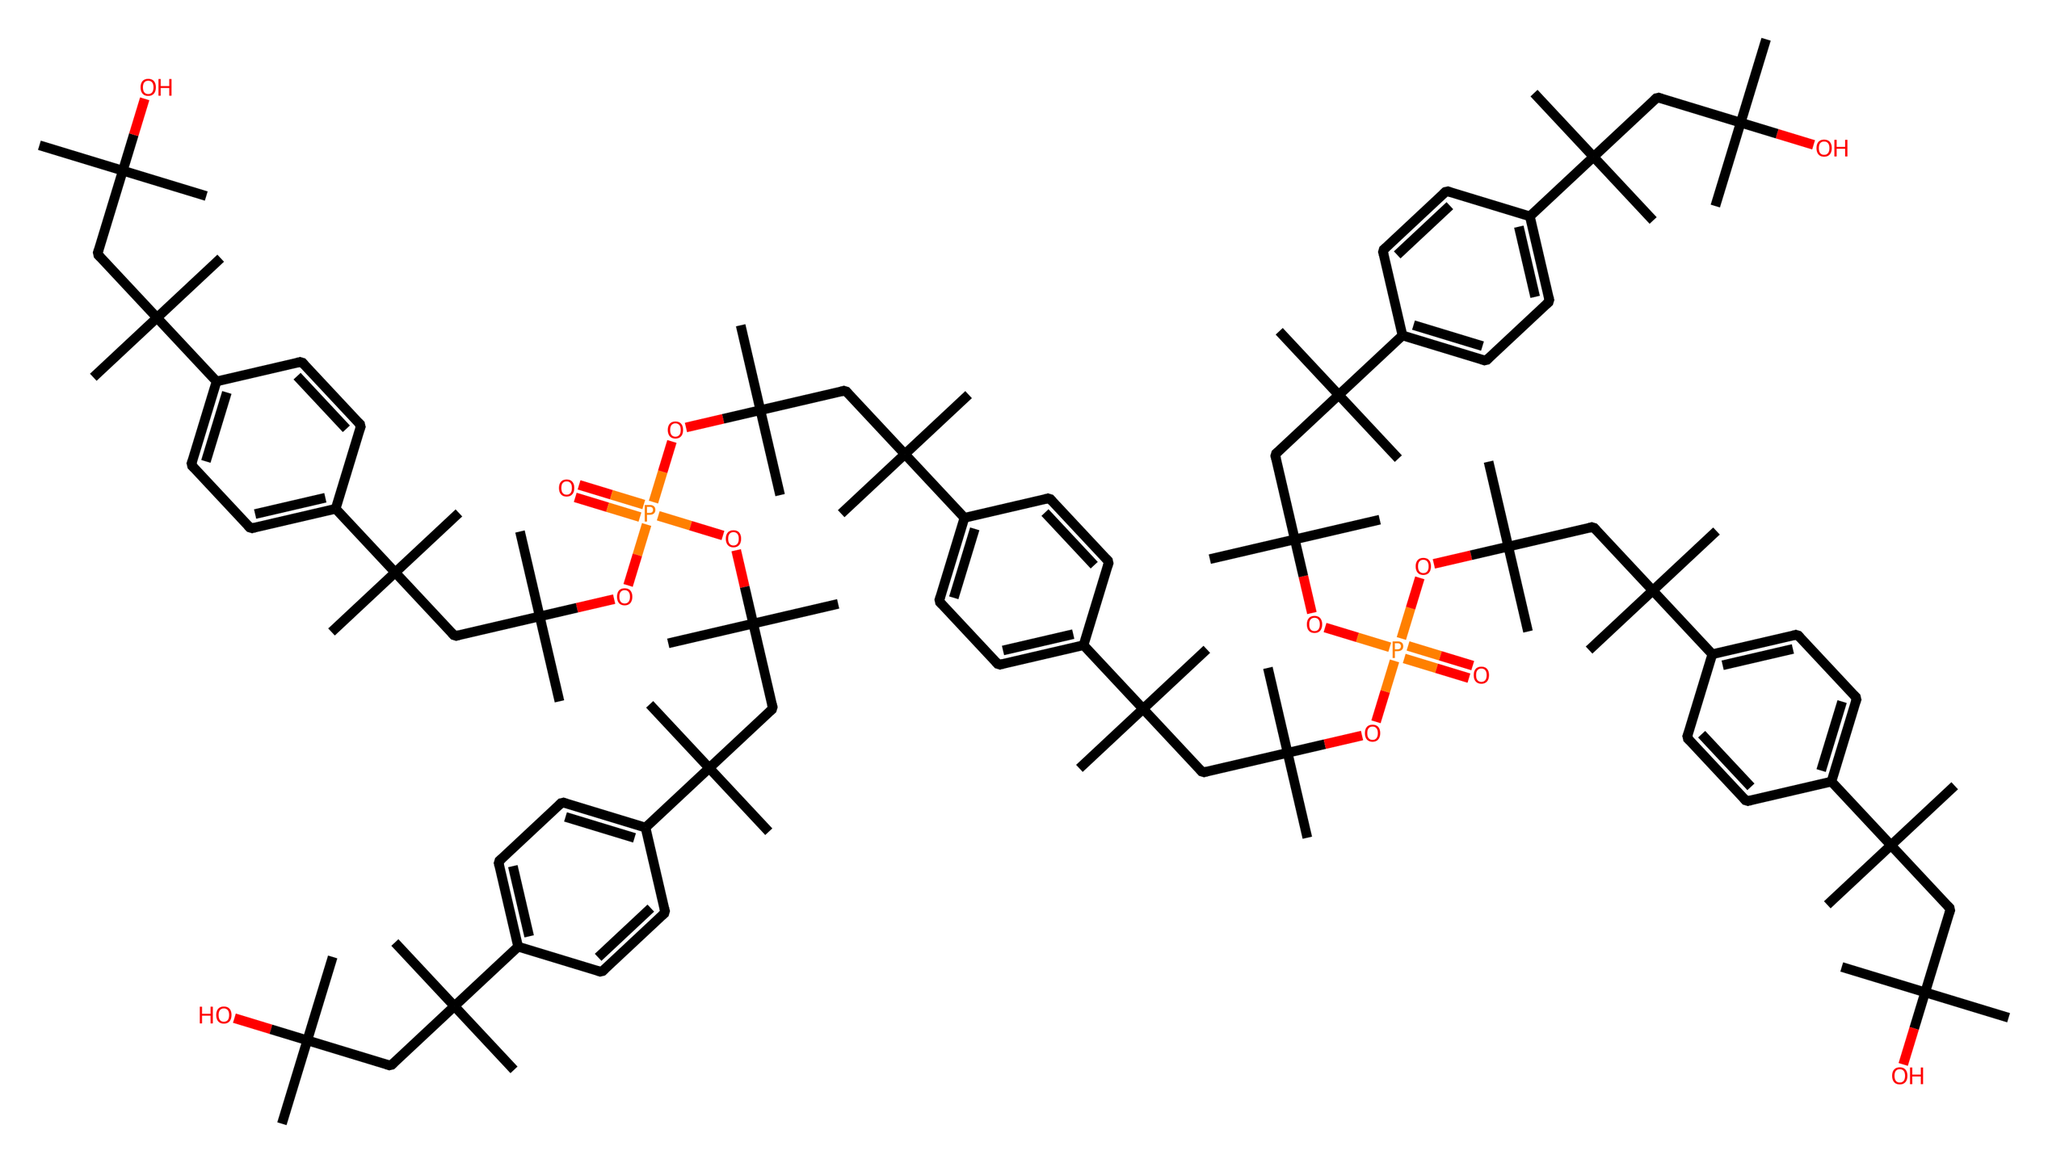What is the core element in this chemical structure? The structure contains phosphorus atoms denoted by the P in the SMILES notation. Therefore, the core element is phosphorus.
Answer: phosphorus How many phosphorus atoms are present in this compound? By analyzing the SMILES representation, we can count the occurrences of the letter P, which appears four times. Hence, there are four phosphorus atoms.
Answer: four What type of functional groups are present in this chemical? The chemical has phosphate groups represented by O=P and various alkoxy groups in the form of OC. Therefore, the main functional groups are phosphates and alkoxy groups.
Answer: phosphates and alkoxy groups What is the total number of carbon atoms in the structure? By examining the structure, we count the carbon atoms that appear in the branches and phenyl groups (c1ccc(cc1)), leading to a total count of 36 carbon atoms.
Answer: thirty-six Identify one characteristic feature of phosphorus flame retardants in this structure. The presence of multiple phosphate groups and branched alkyl chains indicates that these compounds are designed for flame retardancy, providing barrier properties against combustion.
Answer: multiple phosphate groups What type of chemical interactions might be present due to the structure? The phosphate groups can engage in hydrogen bonding and coordinate bonding typical of flame retardants, contributing to their effectiveness in inhibiting fire spread.
Answer: hydrogen bonding and coordinate bonding 